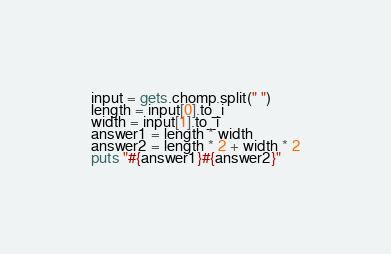Convert code to text. <code><loc_0><loc_0><loc_500><loc_500><_Ruby_>input = gets.chomp.split(" ")
length = input[0].to_i
width = input[1].to_i
answer1 = length * width
answer2 = length * 2 + width * 2
puts "#{answer1}#{answer2}"
</code> 